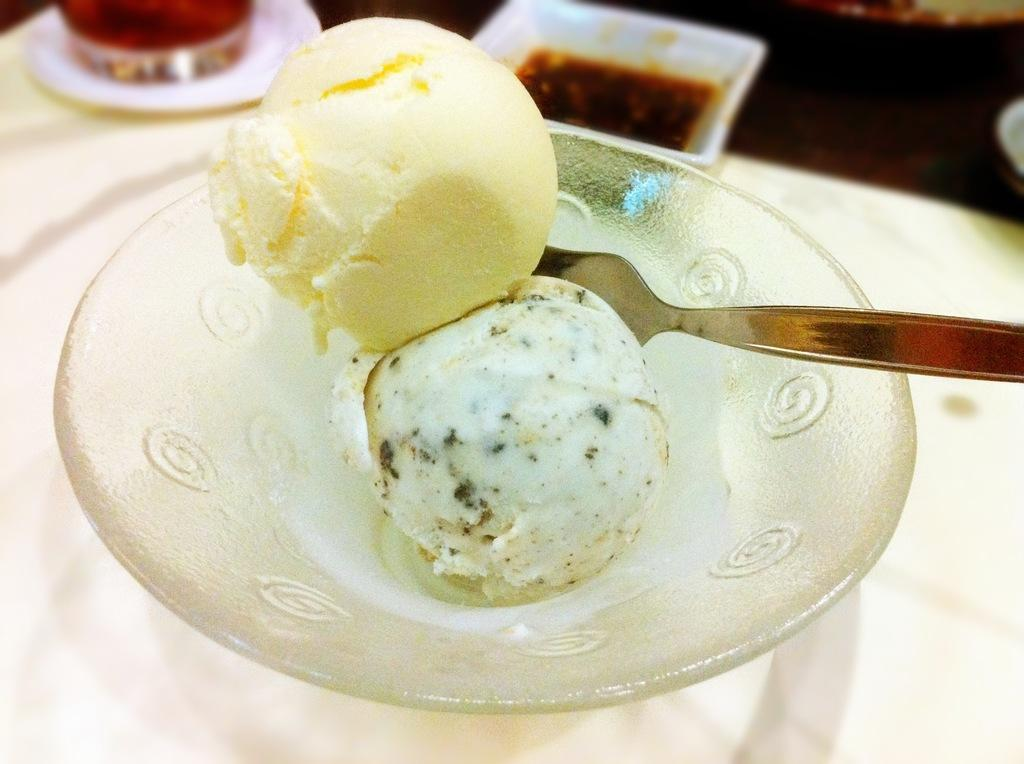What is the main subject in the foreground of the image? There are ice creams in a bowl in the foreground of the image. What utensil is present on the table in the foreground? There is a spoon on the table in the foreground. What can be seen in the top part of the image? There is a white bowl and a saucer in the top part of the image. What other object is on the table in the top part of the image? There is a glass on the table in the top part of the image. What type of mailbox is present in the image? There is no mailbox present in the image. How quiet is the environment in the image? The image does not provide information about the noise level or the environment's quietness. 